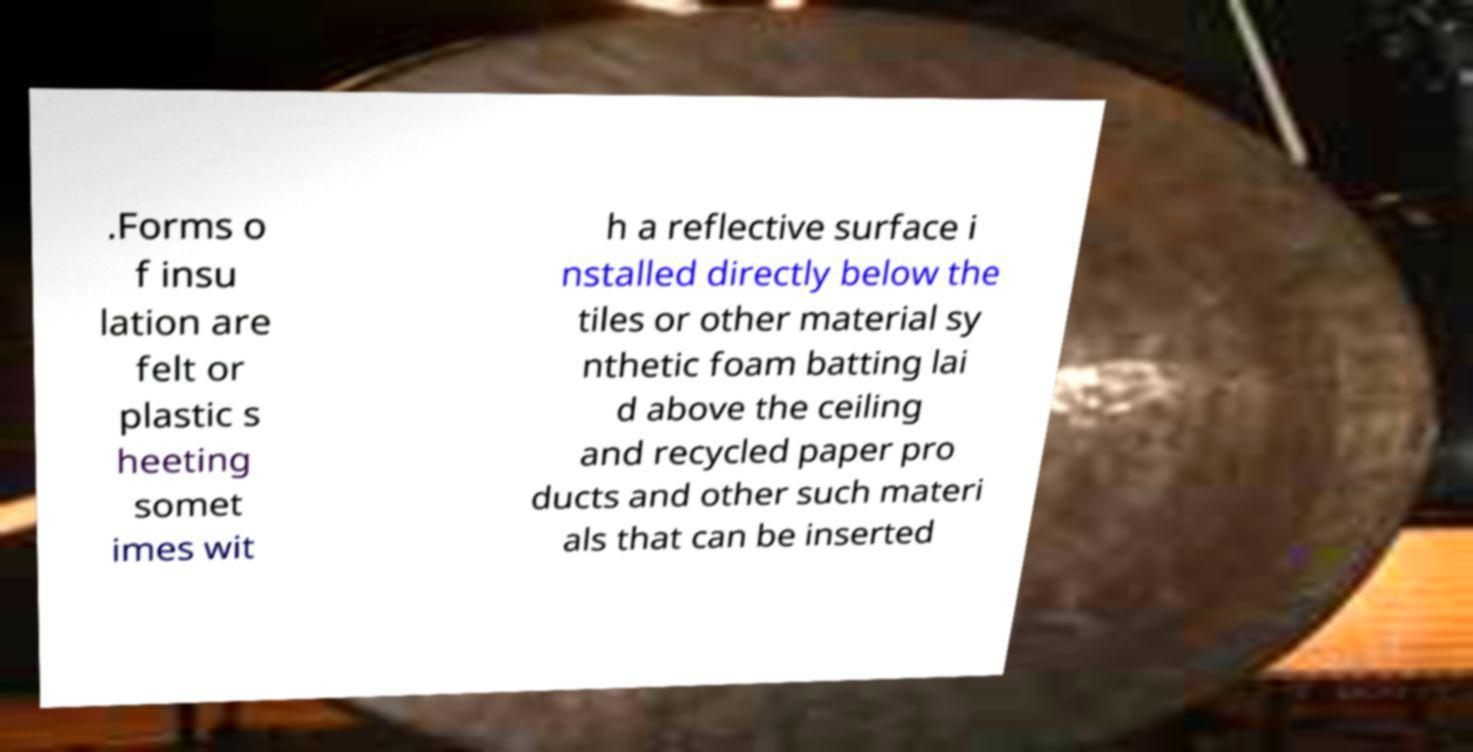Please read and relay the text visible in this image. What does it say? .Forms o f insu lation are felt or plastic s heeting somet imes wit h a reflective surface i nstalled directly below the tiles or other material sy nthetic foam batting lai d above the ceiling and recycled paper pro ducts and other such materi als that can be inserted 